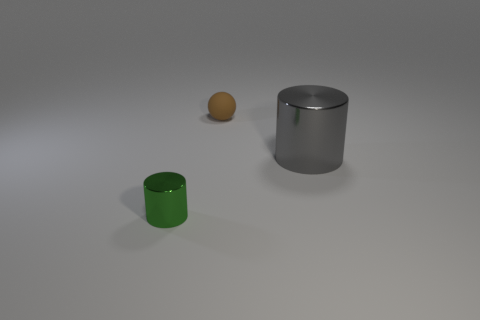What materials do the objects in the image appear to be made of? The objects in the image appear to be made of different materials. The large cylinder on the right seems to be made of a reflective metal, possibly steel or aluminum, due to its shiny surface and solid appearance. The smaller green cylinder looks like it has a matte finish, suggesting it could be painted metal or a plastic material. The small orange spherical object has a slightly reflective surface and might be made of a polished wood or a glossy plastic. 